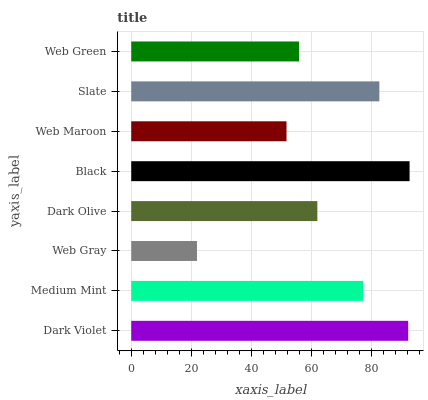Is Web Gray the minimum?
Answer yes or no. Yes. Is Black the maximum?
Answer yes or no. Yes. Is Medium Mint the minimum?
Answer yes or no. No. Is Medium Mint the maximum?
Answer yes or no. No. Is Dark Violet greater than Medium Mint?
Answer yes or no. Yes. Is Medium Mint less than Dark Violet?
Answer yes or no. Yes. Is Medium Mint greater than Dark Violet?
Answer yes or no. No. Is Dark Violet less than Medium Mint?
Answer yes or no. No. Is Medium Mint the high median?
Answer yes or no. Yes. Is Dark Olive the low median?
Answer yes or no. Yes. Is Slate the high median?
Answer yes or no. No. Is Black the low median?
Answer yes or no. No. 